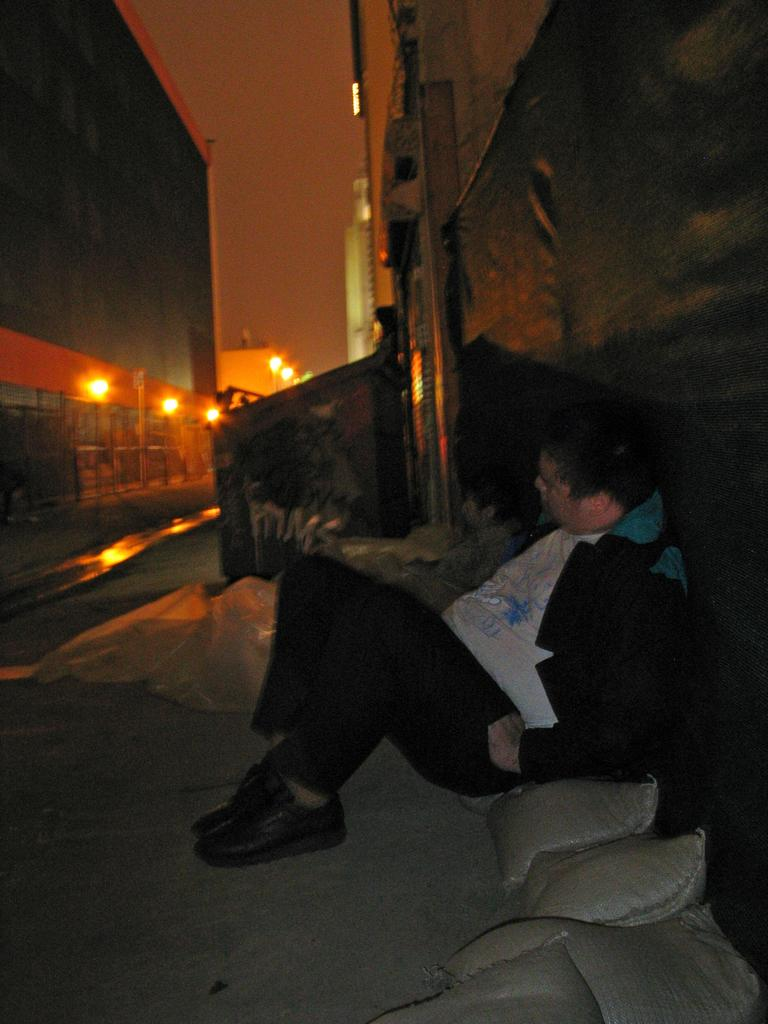What is the person in the image sitting on? The person is sitting on a sack in the image. How many sacks are visible in the image? There are multiple sacks in the image. What type of lighting is present in the image? There are lights in the image. What architectural feature can be seen in the image? There are iron grilles in the image. Can you describe any other items present in the image? There are some other items in the image, but their specific details are not mentioned in the provided facts. What is the porter doing to the person's throat in the image? There is no porter or throat-related activity present in the image. 